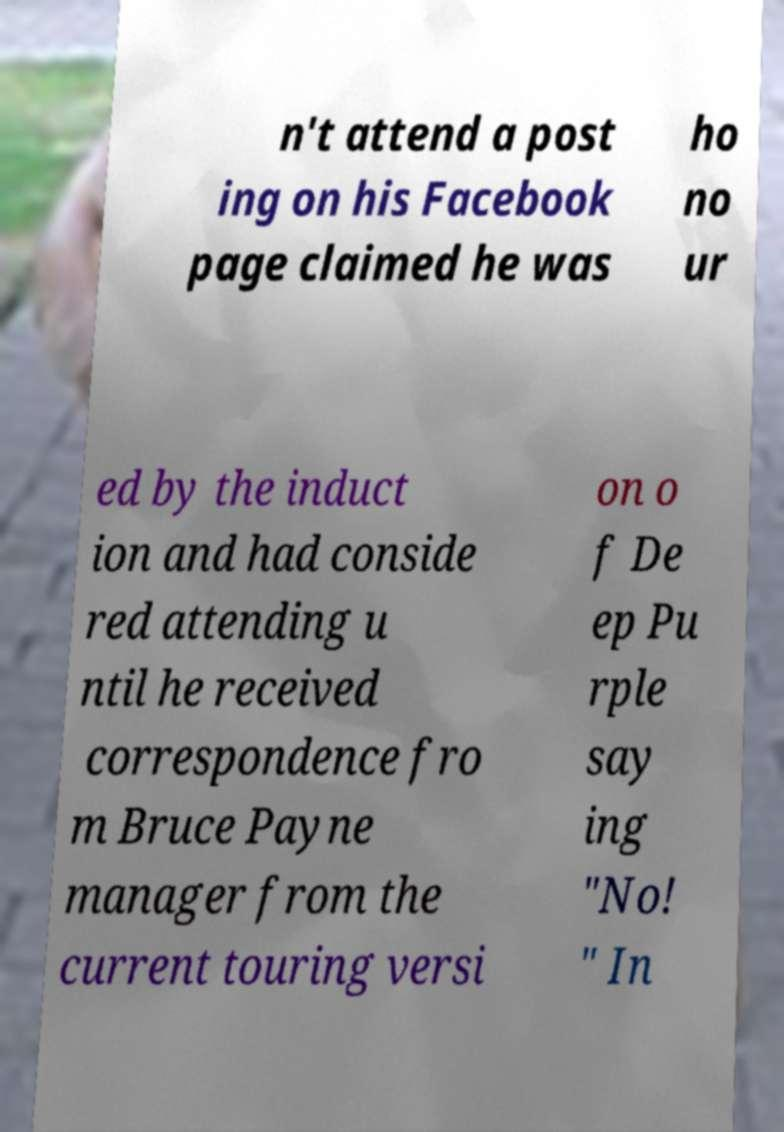I need the written content from this picture converted into text. Can you do that? n't attend a post ing on his Facebook page claimed he was ho no ur ed by the induct ion and had conside red attending u ntil he received correspondence fro m Bruce Payne manager from the current touring versi on o f De ep Pu rple say ing "No! " In 